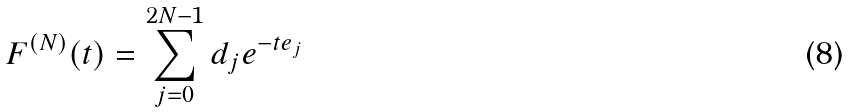<formula> <loc_0><loc_0><loc_500><loc_500>F ^ { ( N ) } ( t ) = \sum _ { j = 0 } ^ { 2 N - 1 } d _ { j } e ^ { - t e _ { j } }</formula> 